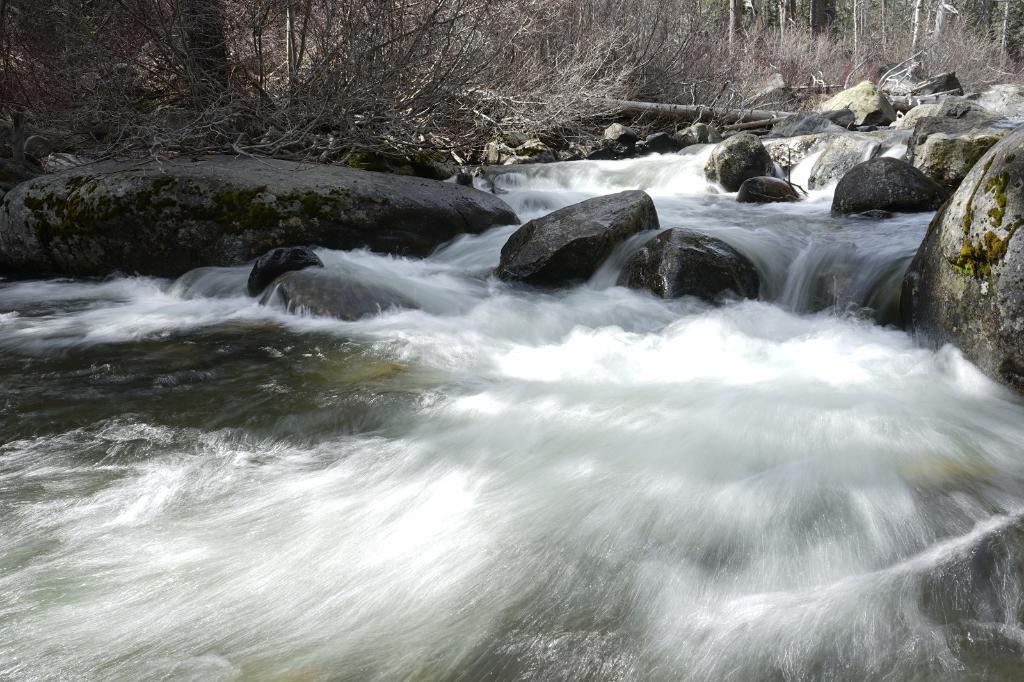What type of natural feature is present in the image? There is a river in the image. What objects can be seen in the river? There are stones in the image. What can be seen in the distance in the image? There are trees in the background of the image. What decision does the rat make in the image? There is no rat present in the image, so no decision can be made. What type of test is being conducted in the image? There is no test being conducted in the image; it features a river, stones, and trees. 